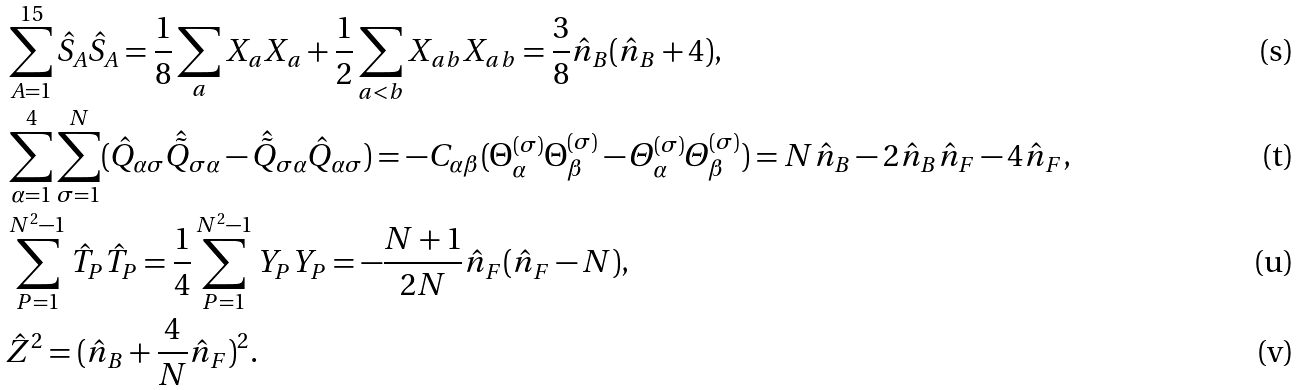Convert formula to latex. <formula><loc_0><loc_0><loc_500><loc_500>& \sum _ { A = 1 } ^ { 1 5 } \hat { S } _ { A } \hat { S } _ { A } = \frac { 1 } { 8 } \sum _ { a } X _ { a } X _ { a } + \frac { 1 } { 2 } \sum _ { a < b } X _ { a b } X _ { a b } = \frac { 3 } { 8 } \hat { n } _ { B } ( \hat { n } _ { B } + 4 ) , \\ & \sum _ { \alpha = 1 } ^ { 4 } \sum _ { \sigma = 1 } ^ { N } ( \hat { Q } _ { \alpha \sigma } \hat { \tilde { Q } } _ { \sigma \alpha } - \hat { \tilde { Q } } _ { \sigma \alpha } \hat { Q } _ { \alpha \sigma } ) = - C _ { \alpha \beta } ( \Theta _ { \alpha } ^ { ( \sigma ) } \Theta _ { \beta } ^ { ( \sigma ) } - \varTheta _ { \alpha } ^ { ( \sigma ) } \varTheta _ { \beta } ^ { ( \sigma ) } ) = N \hat { n } _ { B } - 2 \hat { n } _ { B } \hat { n } _ { F } - 4 \hat { n } _ { F } , \\ & \sum _ { P = 1 } ^ { N ^ { 2 } - 1 } \hat { T } _ { P } \hat { T } _ { P } = \frac { 1 } { 4 } \sum _ { P = 1 } ^ { N ^ { 2 } - 1 } Y _ { P } Y _ { P } = - \frac { N + 1 } { 2 N } \hat { n } _ { F } ( \hat { n } _ { F } - N ) , \\ & \hat { Z } ^ { 2 } = ( \hat { n } _ { B } + \frac { 4 } { N } \hat { n } _ { F } ) ^ { 2 } .</formula> 